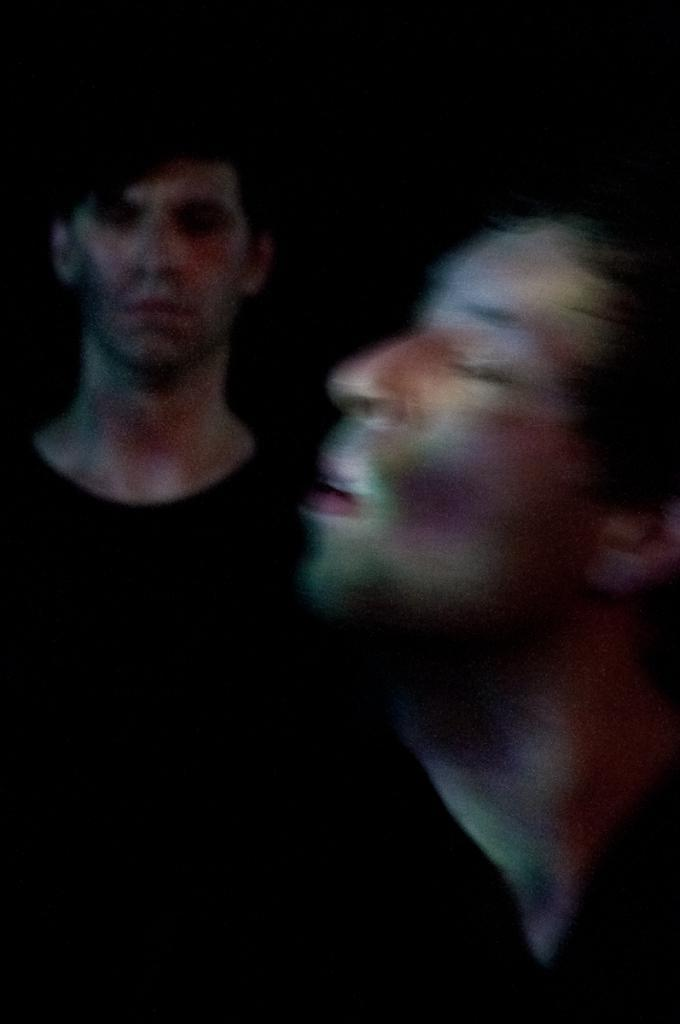How many people are in the image? There are two members in the image. What can be observed about the background of the image? The background of the image is dark. What type of tramp is visible in the image? There is no tramp present in the image. How many times has the image been twisted before being captured? The image has not been twisted; it is a still photograph. 